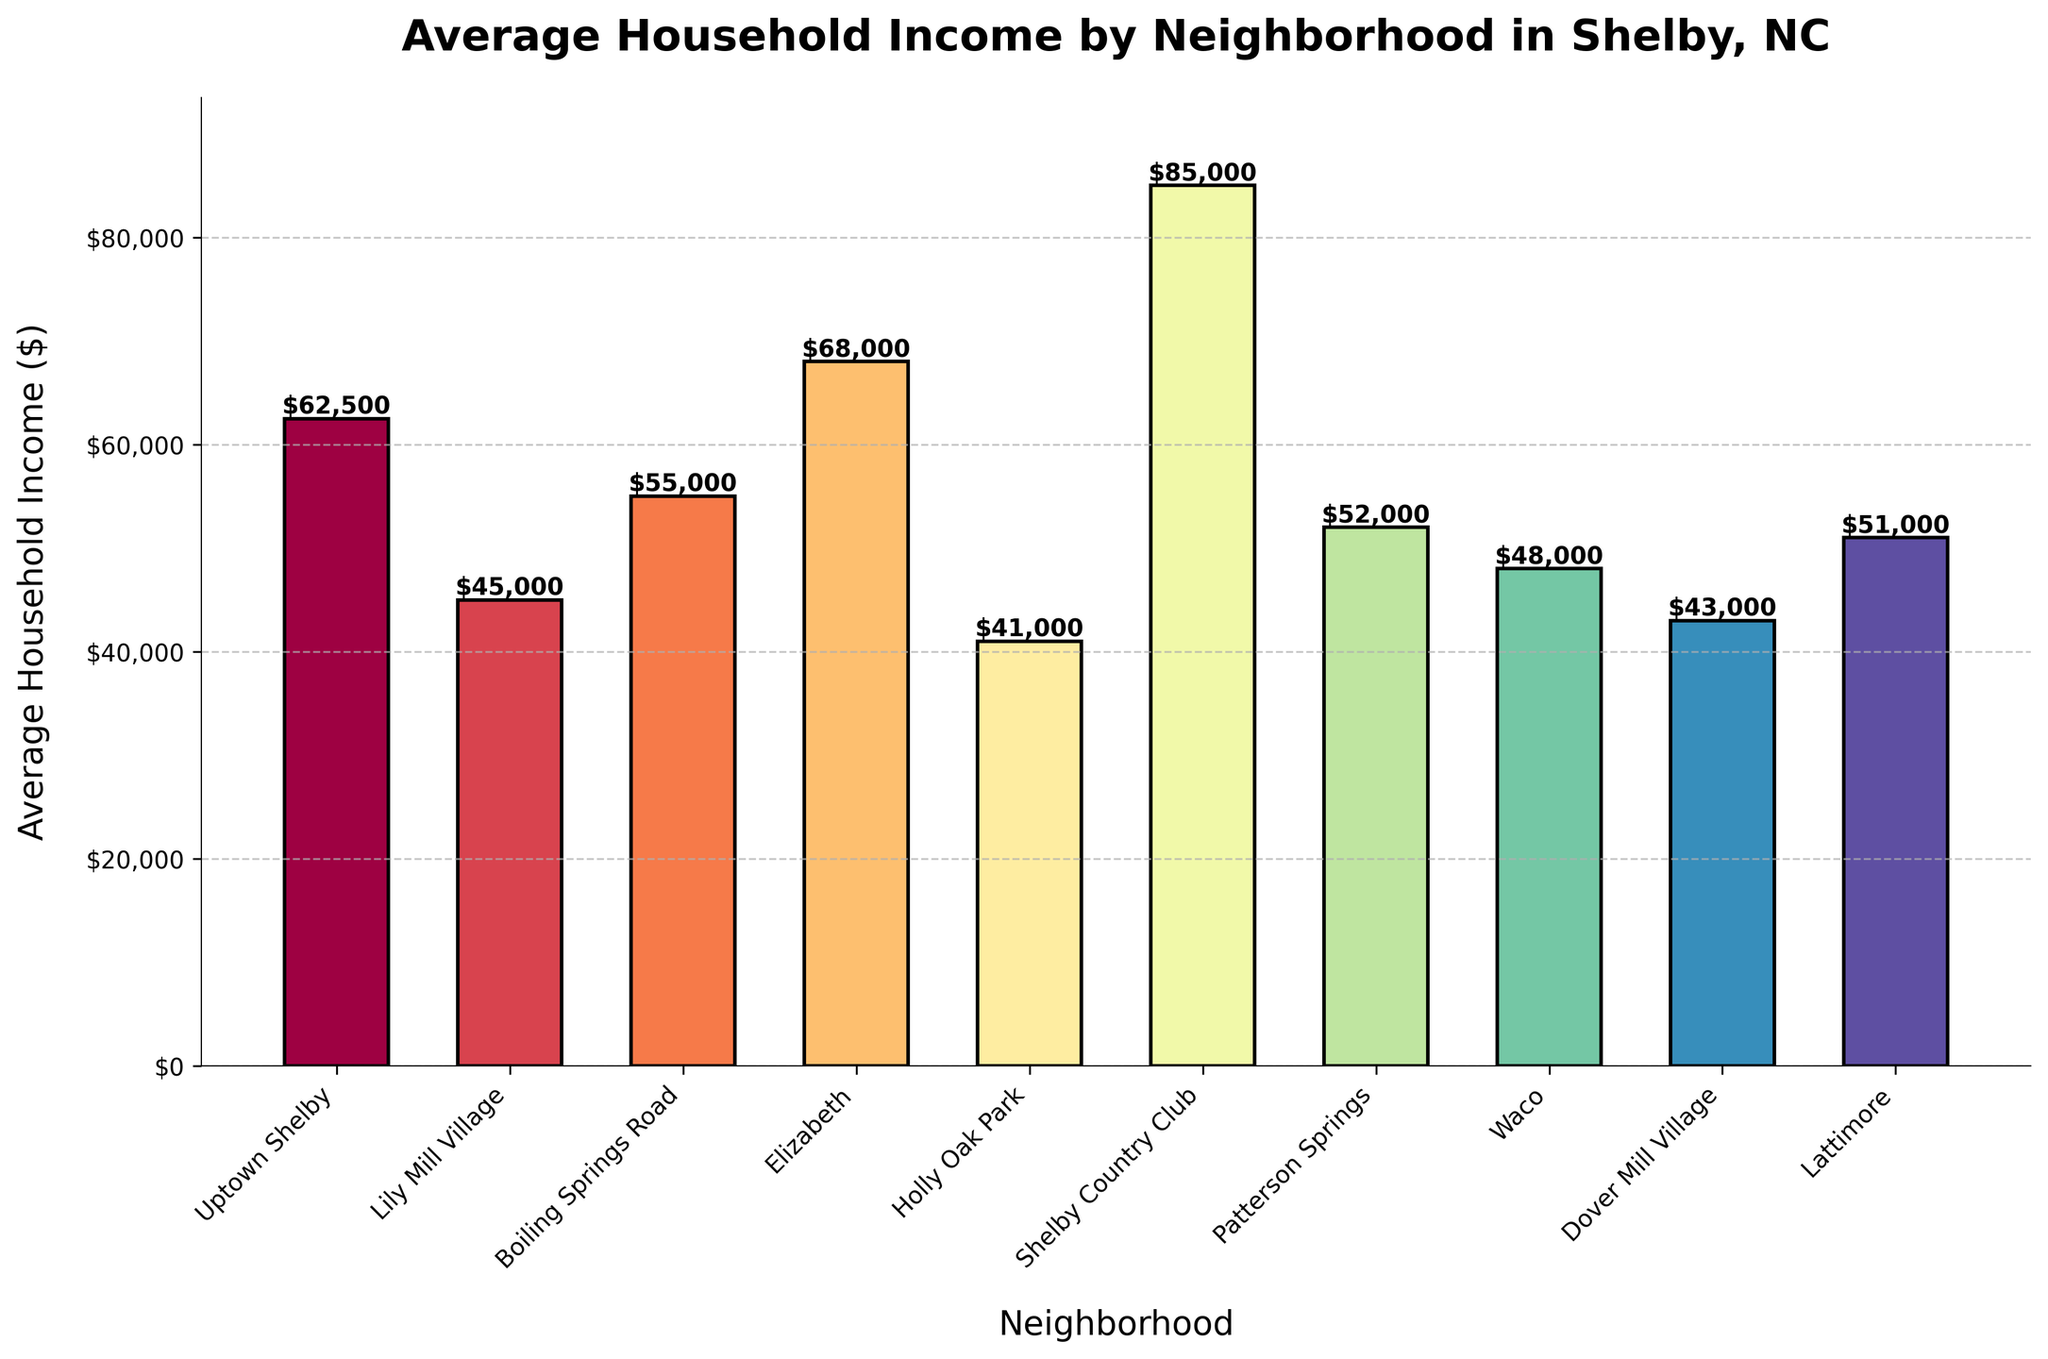What's the title of the figure? The title is typically located at the top of the figure. In this case, it shows "Average Household Income by Neighborhood in Shelby, NC".
Answer: Average Household Income by Neighborhood in Shelby, NC What is the average household income of the Shelby Country Club neighborhood? Look for the bar labeled "Shelby Country Club" and read the value. The top of the bar shows the amount at $85,000.
Answer: $85,000 Which neighborhood has the lowest average household income, and what is that income? Identify the shortest bar in the figure. This corresponds to the Holly Oak Park neighborhood, with the income of $41,000.
Answer: Holly Oak Park, $41,000 How many neighborhoods have an average household income above $50,000? Count the number of bars that exceed the $50,000 mark. Uptown Shelby, Boiling Springs Road, Elizabeth, Shelby Country Club, and Lattimore meet this criterion. There are 5 neighborhoods in total.
Answer: 5 What is the difference in average household income between Shelby Country Club and Holly Oak Park? Subtract the average household income of Holly Oak Park ($41,000) from that of Shelby Country Club ($85,000). The calculation is $85,000 - $41,000 = $44,000.
Answer: $44,000 What is the average household income of the neighborhoods with incomes below $50,000? Identify the neighborhoods below $50,000: Lily Mill Village ($45,000), Holly Oak Park ($41,000), Dover Mill Village ($43,000), and Waco ($48,000). Compute their average by summing the incomes and dividing by the number of neighborhoods, i.e., ($45,000 + $41,000 + $43,000 + $48,000) / 4 = $177,000 / 4 = $44,250.
Answer: $44,250 Which neighborhood has the highest average household income, and what is that amount? Identify the tallest bar. This corresponds to Shelby Country Club with an income of $85,000.
Answer: Shelby Country Club, $85,000 How does the average household income of Uptown Shelby compare to Boiling Springs Road? Locate the bars for Uptown Shelby ($62,500) and Boiling Springs Road ($55,000) and compare their heights. Uptown Shelby has a higher average household income by $7,500.
Answer: Uptown Shelby is higher by $7,500 What is the sum of the average household incomes of Elizabeth and Boiling Springs Road? Add the average household incomes of Elizabeth ($68,000) and Boiling Springs Road ($55,000). The calculation is $68,000 + $55,000 = $123,000.
Answer: $123,000 What is the median average household income of all the neighborhoods? Arrange the incomes in ascending order ($41,000, $43,000, $45,000, $48,000, $50,000, $55,000, $62,500, $68,000, $85,000) and find the middle value. Since there are 10 values, the median is the average of the 5th and 6th values, i.e., ($50,000 + $55,000) / 2 = $52,500.
Answer: $52,500 